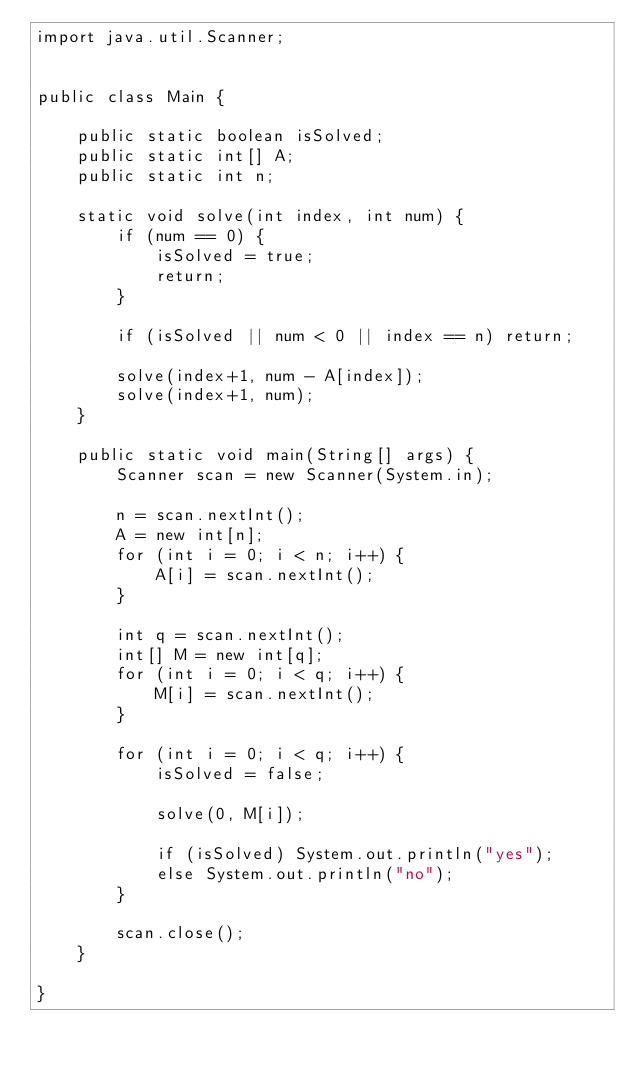<code> <loc_0><loc_0><loc_500><loc_500><_Java_>import java.util.Scanner;


public class Main {

	public static boolean isSolved;
	public static int[] A;
	public static int n;
	
	static void solve(int index, int num) {
		if (num == 0) {
			isSolved = true;
			return;
		}

		if (isSolved || num < 0 || index == n) return;
		
		solve(index+1, num - A[index]);
		solve(index+1, num);
	}
	
	public static void main(String[] args) {
		Scanner scan = new Scanner(System.in);

		n = scan.nextInt();
		A = new int[n];
		for (int i = 0; i < n; i++) {
			A[i] = scan.nextInt();
		}
		
		int q = scan.nextInt();
		int[] M = new int[q];
		for (int i = 0; i < q; i++) {
			M[i] = scan.nextInt();
		}
		
		for (int i = 0; i < q; i++) {
			isSolved = false;
			
			solve(0, M[i]);
			
			if (isSolved) System.out.println("yes");
			else System.out.println("no");
		}
		
		scan.close();
	}

}</code> 